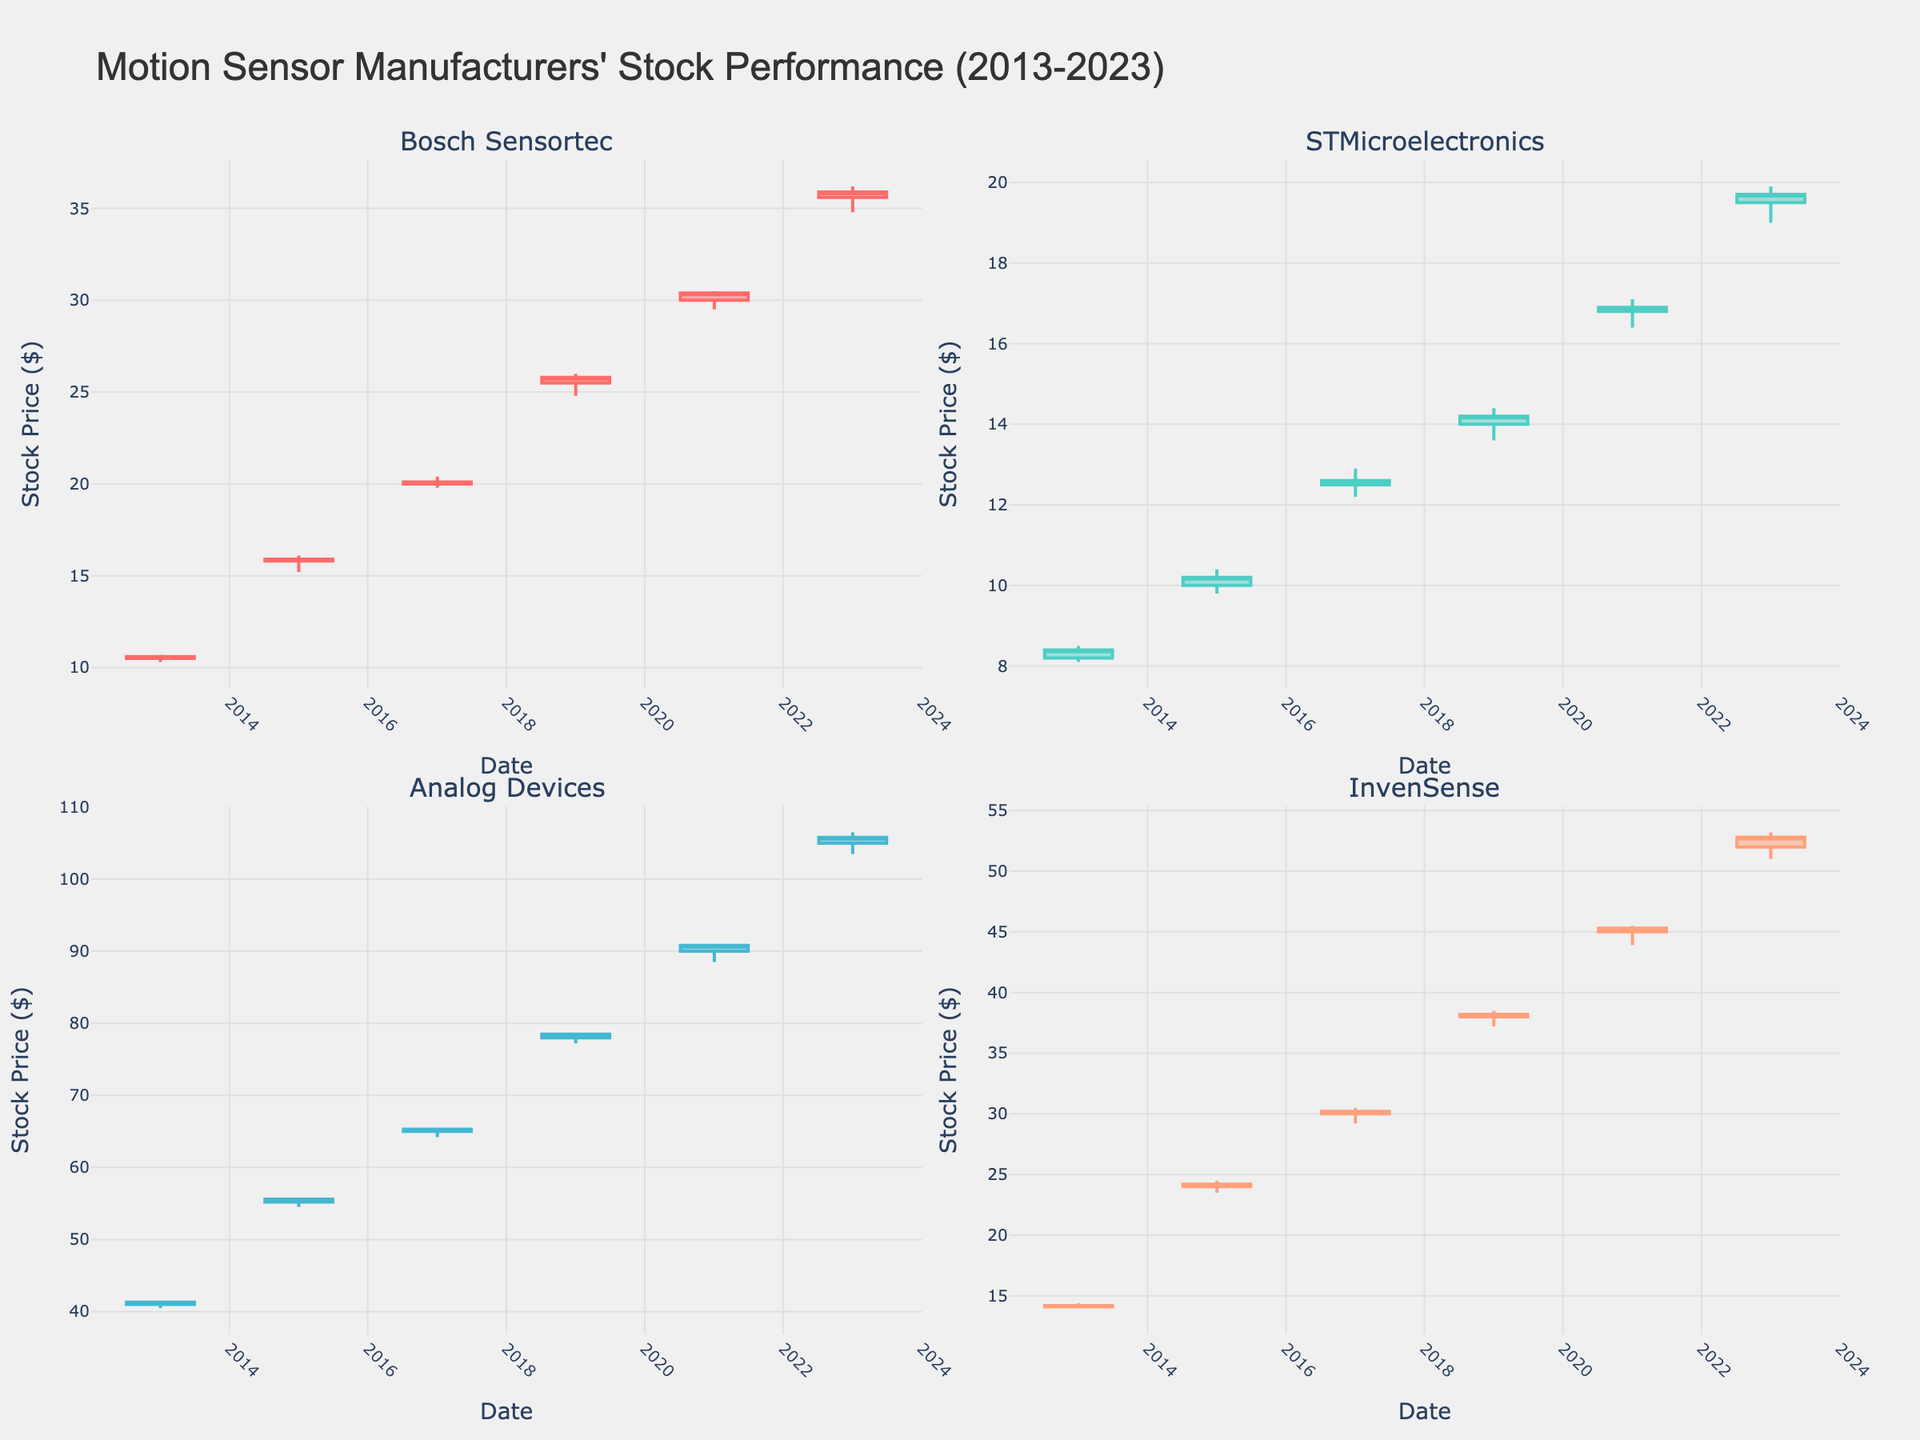Which company had the highest stock price on January 2, 2023? Look at the subplots for each company and compare the 'High' values on January 2, 2023. Analog Devices' subplot shows a high of $106.50, which is the highest among all companies.
Answer: Analog Devices How has Bosch Sensortec's stock price changed from January 2, 2013, to January 2, 2023? Observe the Bosch Sensortec subplot and compare the 'Open' values on January 2, 2013 ($10.50) and January 2, 2023 ($35.60). The stock price increased by $25.10 over the decade.
Answer: Increased by $25.10 Which company showed the most significant percentage increase in stock price over the presented years? Calculate the percentage increase for each company using the formula [(Final Open - Initial Open) / Initial Open] * 100. Bosch Sensortec shows an increase from $10.50 to $35.60, resulting in the highest percentage increase.
Answer: Bosch Sensortec What is the lowest 'Low' value recorded for InvenSense over the time period shown? Examine InvenSense's subplot and look for the lowest 'Low' value across all dates. The lowest value is $14.00 on January 2, 2013.
Answer: $14.00 Which year had the highest trading volume for STMicroelectronics? Check the volume of trades for STMicroelectronics in each of the years shown. The highest volume is 2,300,000 on January 2, 2023.
Answer: 2023 Did Analog Devices' stock price ever close lower than it opened on any given year? Observe the Analog Devices subplot for any instances where the 'Close' value is less than the 'Open' across all dates. There are no such instances in the given data.
Answer: No Compare the stock price trends of Bosch Sensortec and STMicroelectronics over the decade. Which company showed a more consistent upward trend? Review both subplots for patterns in the rise of 'Open' values. Bosch Sensortec shows a more consistent upward trend from $10.50 to $35.60, while STMicroelectronics has smaller, less consistent increments.
Answer: Bosch Sensortec Which two years show the biggest difference in opening stock prices for Analog Devices? Compare the 'Open' values for Analog Devices across all dates. The biggest difference is between January 2, 2013 ($41.00) and January 2, 2023 ($105.00), a difference of $64.00.
Answer: 2013 and 2023 